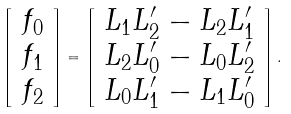<formula> <loc_0><loc_0><loc_500><loc_500>\left [ \begin{array} { c c c } f _ { 0 } \\ f _ { 1 } \\ f _ { 2 } \end{array} \right ] = \left [ \begin{array} { c c c } L _ { 1 } L ^ { \prime } _ { 2 } - L _ { 2 } L ^ { \prime } _ { 1 } \\ L _ { 2 } L ^ { \prime } _ { 0 } - L _ { 0 } L ^ { \prime } _ { 2 } \\ L _ { 0 } L ^ { \prime } _ { 1 } - L _ { 1 } L ^ { \prime } _ { 0 } \end{array} \right ] .</formula> 